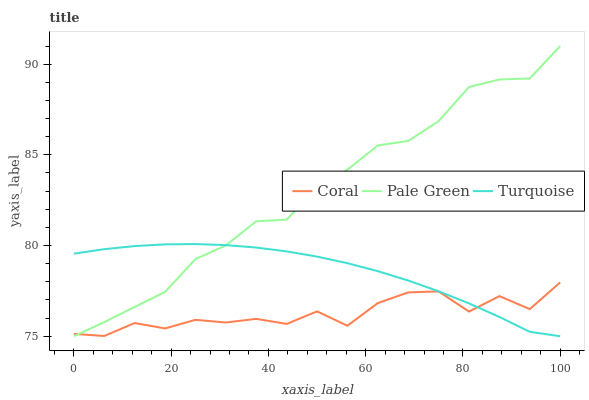Does Coral have the minimum area under the curve?
Answer yes or no. Yes. Does Pale Green have the maximum area under the curve?
Answer yes or no. Yes. Does Turquoise have the minimum area under the curve?
Answer yes or no. No. Does Turquoise have the maximum area under the curve?
Answer yes or no. No. Is Turquoise the smoothest?
Answer yes or no. Yes. Is Coral the roughest?
Answer yes or no. Yes. Is Pale Green the smoothest?
Answer yes or no. No. Is Pale Green the roughest?
Answer yes or no. No. Does Pale Green have the lowest value?
Answer yes or no. Yes. Does Pale Green have the highest value?
Answer yes or no. Yes. Does Turquoise have the highest value?
Answer yes or no. No. Does Turquoise intersect Coral?
Answer yes or no. Yes. Is Turquoise less than Coral?
Answer yes or no. No. Is Turquoise greater than Coral?
Answer yes or no. No. 